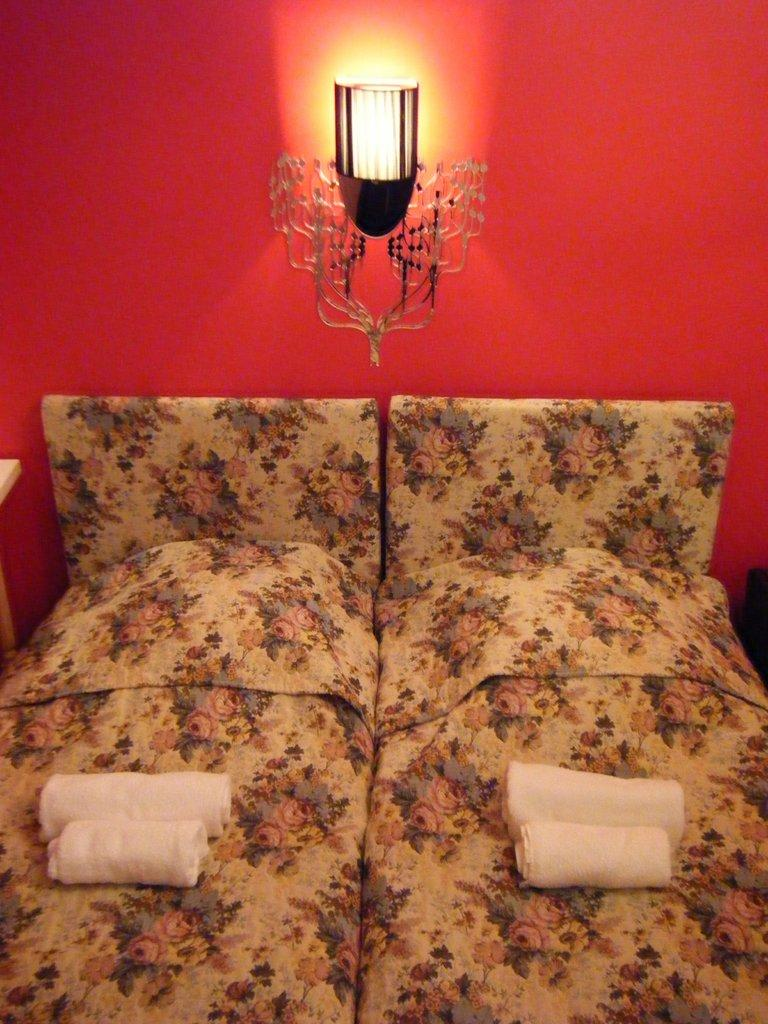How many beds are visible in the image? There are two beds in the image. What can be seen on top of the beds? There are white color towels on the beds. What type of lighting fixture is present in the image? There is a lamp in the middle of the image. How is the lamp positioned in the image? The lamp is attached to the wall. What is the rate of the argument between the two beds in the image? There is no argument present in the image, as it features two beds with white towels and a lamp attached to the wall. 